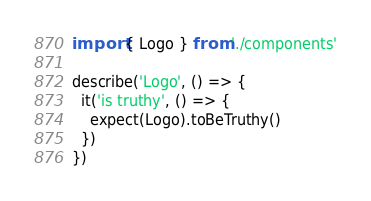Convert code to text. <code><loc_0><loc_0><loc_500><loc_500><_TypeScript_>import { Logo } from './components'

describe('Logo', () => {
  it('is truthy', () => {
    expect(Logo).toBeTruthy()
  })
})
</code> 